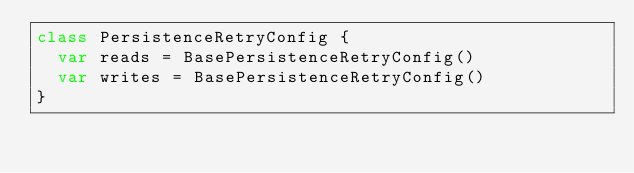Convert code to text. <code><loc_0><loc_0><loc_500><loc_500><_Kotlin_>class PersistenceRetryConfig {
  var reads = BasePersistenceRetryConfig()
  var writes = BasePersistenceRetryConfig()
}
</code> 